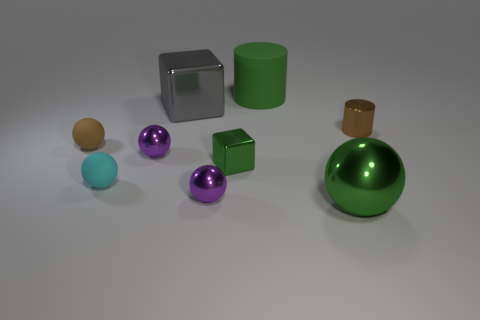What color is the other matte object that is the same shape as the cyan thing?
Provide a short and direct response. Brown. Is there anything else that is the same shape as the tiny green object?
Make the answer very short. Yes. There is a tiny brown thing that is to the right of the small green metal object; does it have the same shape as the rubber object that is behind the tiny brown cylinder?
Make the answer very short. Yes. There is a brown metal object; is it the same size as the green metal object right of the tiny block?
Keep it short and to the point. No. Are there more purple balls than shiny balls?
Give a very brief answer. No. Are the small brown thing that is on the left side of the big green ball and the cylinder behind the small metallic cylinder made of the same material?
Your response must be concise. Yes. What is the material of the small cyan sphere?
Keep it short and to the point. Rubber. Are there more small cubes in front of the small brown matte sphere than large cyan metallic blocks?
Provide a short and direct response. Yes. What number of large gray things are on the right side of the tiny purple metallic object behind the small shiny block that is to the left of the big green shiny ball?
Give a very brief answer. 1. There is a big object that is behind the small cyan ball and right of the green metallic block; what is it made of?
Provide a short and direct response. Rubber. 